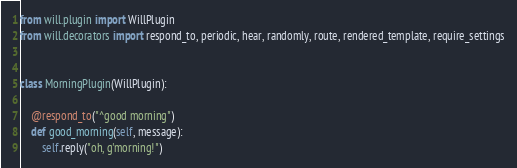<code> <loc_0><loc_0><loc_500><loc_500><_Python_>from will.plugin import WillPlugin
from will.decorators import respond_to, periodic, hear, randomly, route, rendered_template, require_settings


class MorningPlugin(WillPlugin):

    @respond_to("^good morning")
    def good_morning(self, message):
        self.reply("oh, g'morning!")
</code> 